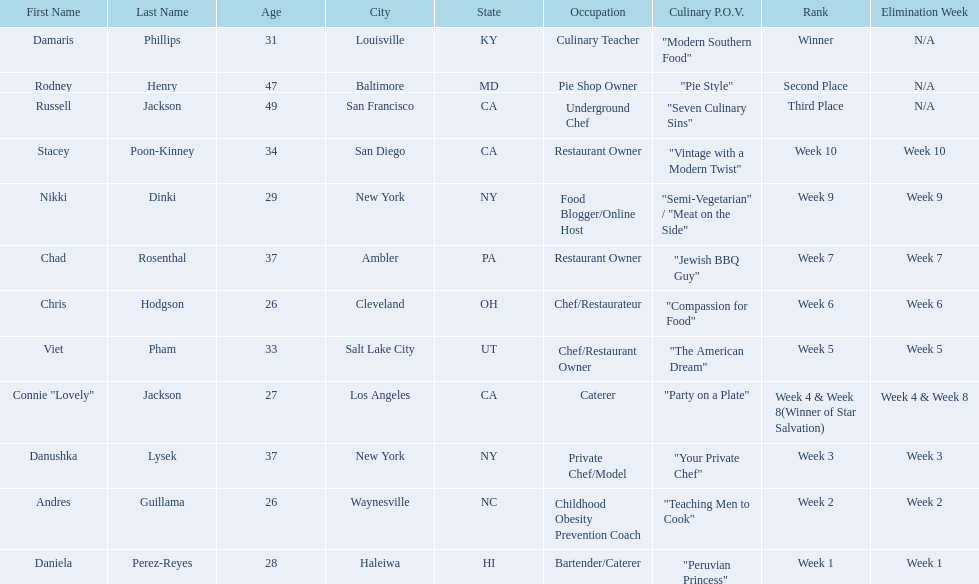Can you give me this table as a dict? {'header': ['First Name', 'Last Name', 'Age', 'City', 'State', 'Occupation', 'Culinary P.O.V.', 'Rank', 'Elimination Week'], 'rows': [['Damaris', 'Phillips', '31', 'Louisville', 'KY', 'Culinary Teacher', '"Modern Southern Food"', 'Winner', 'N/A'], ['Rodney', 'Henry', '47', 'Baltimore', 'MD', 'Pie Shop Owner', '"Pie Style"', 'Second Place', 'N/A'], ['Russell', 'Jackson', '49', 'San Francisco', 'CA', 'Underground Chef', '"Seven Culinary Sins"', 'Third Place', 'N/A'], ['Stacey', 'Poon-Kinney', '34', 'San Diego', 'CA', 'Restaurant Owner', '"Vintage with a Modern Twist"', 'Week 10', 'Week 10'], ['Nikki', 'Dinki', '29', 'New York', 'NY', 'Food Blogger/Online Host', '"Semi-Vegetarian" / "Meat on the Side"', 'Week 9', 'Week 9'], ['Chad', 'Rosenthal', '37', 'Ambler', 'PA', 'Restaurant Owner', '"Jewish BBQ Guy"', 'Week 7', 'Week 7'], ['Chris', 'Hodgson', '26', 'Cleveland', 'OH', 'Chef/Restaurateur', '"Compassion for Food"', 'Week 6', 'Week 6'], ['Viet', 'Pham', '33', 'Salt Lake City', 'UT', 'Chef/Restaurant Owner', '"The American Dream"', 'Week 5', 'Week 5'], ['Connie "Lovely"', 'Jackson', '27', 'Los Angeles', 'CA', 'Caterer', '"Party on a Plate"', 'Week 4 & Week 8(Winner of Star Salvation)', 'Week 4 & Week 8'], ['Danushka', 'Lysek', '37', 'New York', 'NY', 'Private Chef/Model', '"Your Private Chef"', 'Week 3', 'Week 3'], ['Andres', 'Guillama', '26', 'Waynesville', 'NC', 'Childhood Obesity Prevention Coach', '"Teaching Men to Cook"', 'Week 2', 'Week 2'], ['Daniela', 'Perez-Reyes', '28', 'Haleiwa', 'HI', 'Bartender/Caterer', '"Peruvian Princess"', 'Week 1', 'Week 1']]} Who was eliminated first, nikki dinki or viet pham? Viet Pham. 